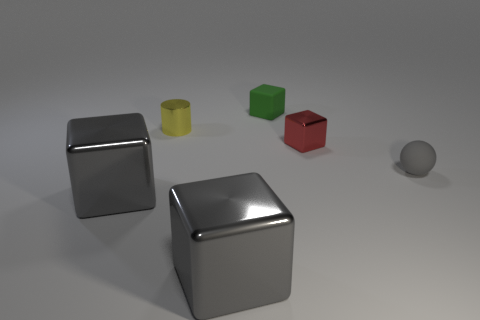Add 1 big gray shiny things. How many objects exist? 7 Subtract all balls. How many objects are left? 5 Add 6 small spheres. How many small spheres are left? 7 Add 5 metal things. How many metal things exist? 9 Subtract 0 purple blocks. How many objects are left? 6 Subtract all large blue spheres. Subtract all tiny metal things. How many objects are left? 4 